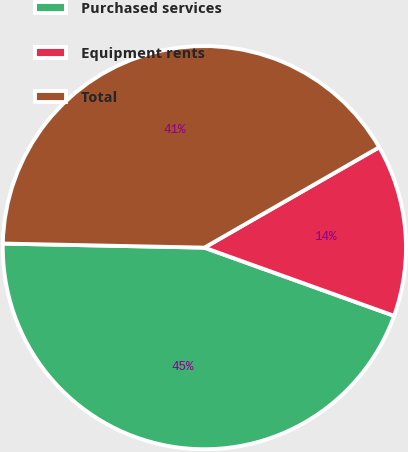Convert chart to OTSL. <chart><loc_0><loc_0><loc_500><loc_500><pie_chart><fcel>Purchased services<fcel>Equipment rents<fcel>Total<nl><fcel>44.83%<fcel>13.79%<fcel>41.38%<nl></chart> 